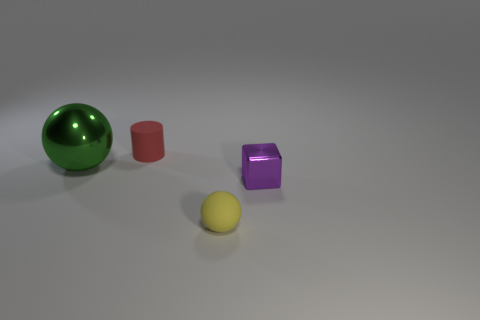Add 4 tiny purple cubes. How many objects exist? 8 Add 3 big green metallic things. How many big green metallic things are left? 4 Add 2 cyan shiny blocks. How many cyan shiny blocks exist? 2 Subtract 0 blue spheres. How many objects are left? 4 Subtract all cylinders. How many objects are left? 3 Subtract all gray cubes. Subtract all cyan cylinders. How many cubes are left? 1 Subtract all big brown matte cubes. Subtract all tiny red cylinders. How many objects are left? 3 